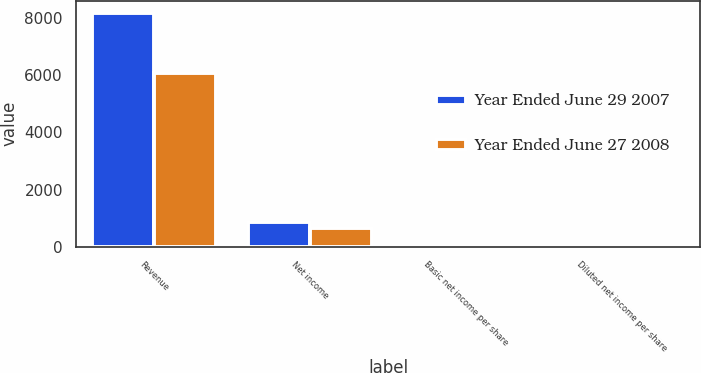Convert chart. <chart><loc_0><loc_0><loc_500><loc_500><stacked_bar_chart><ecel><fcel>Revenue<fcel>Net income<fcel>Basic net income per share<fcel>Diluted net income per share<nl><fcel>Year Ended June 29 2007<fcel>8183<fcel>850<fcel>3.85<fcel>3.76<nl><fcel>Year Ended June 27 2008<fcel>6060<fcel>656<fcel>3<fcel>2.9<nl></chart> 